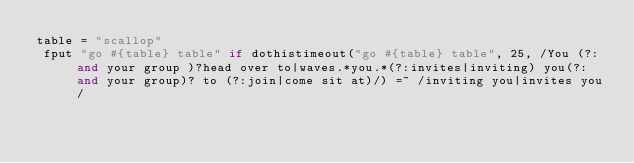<code> <loc_0><loc_0><loc_500><loc_500><_Ruby_>table = "scallop"
 fput "go #{table} table" if dothistimeout("go #{table} table", 25, /You (?:and your group )?head over to|waves.*you.*(?:invites|inviting) you(?: and your group)? to (?:join|come sit at)/) =~ /inviting you|invites you/</code> 